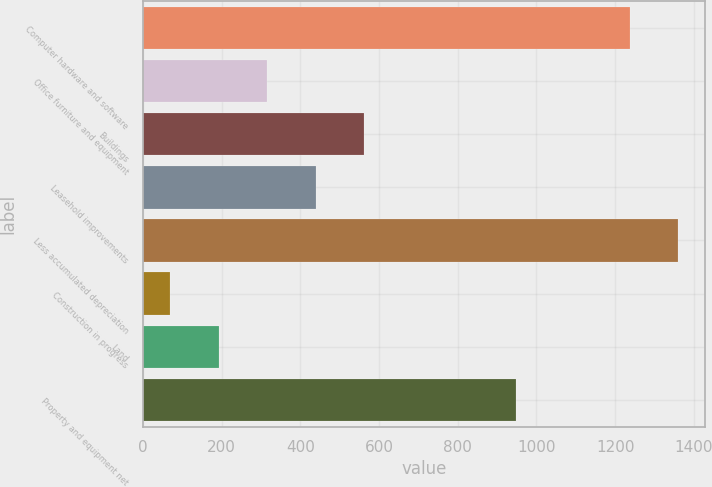<chart> <loc_0><loc_0><loc_500><loc_500><bar_chart><fcel>Computer hardware and software<fcel>Office furniture and equipment<fcel>Buildings<fcel>Leasehold improvements<fcel>Less accumulated depreciation<fcel>Construction in progress<fcel>Land<fcel>Property and equipment net<nl><fcel>1237<fcel>315.8<fcel>561.6<fcel>438.7<fcel>1359.9<fcel>70<fcel>192.9<fcel>949<nl></chart> 